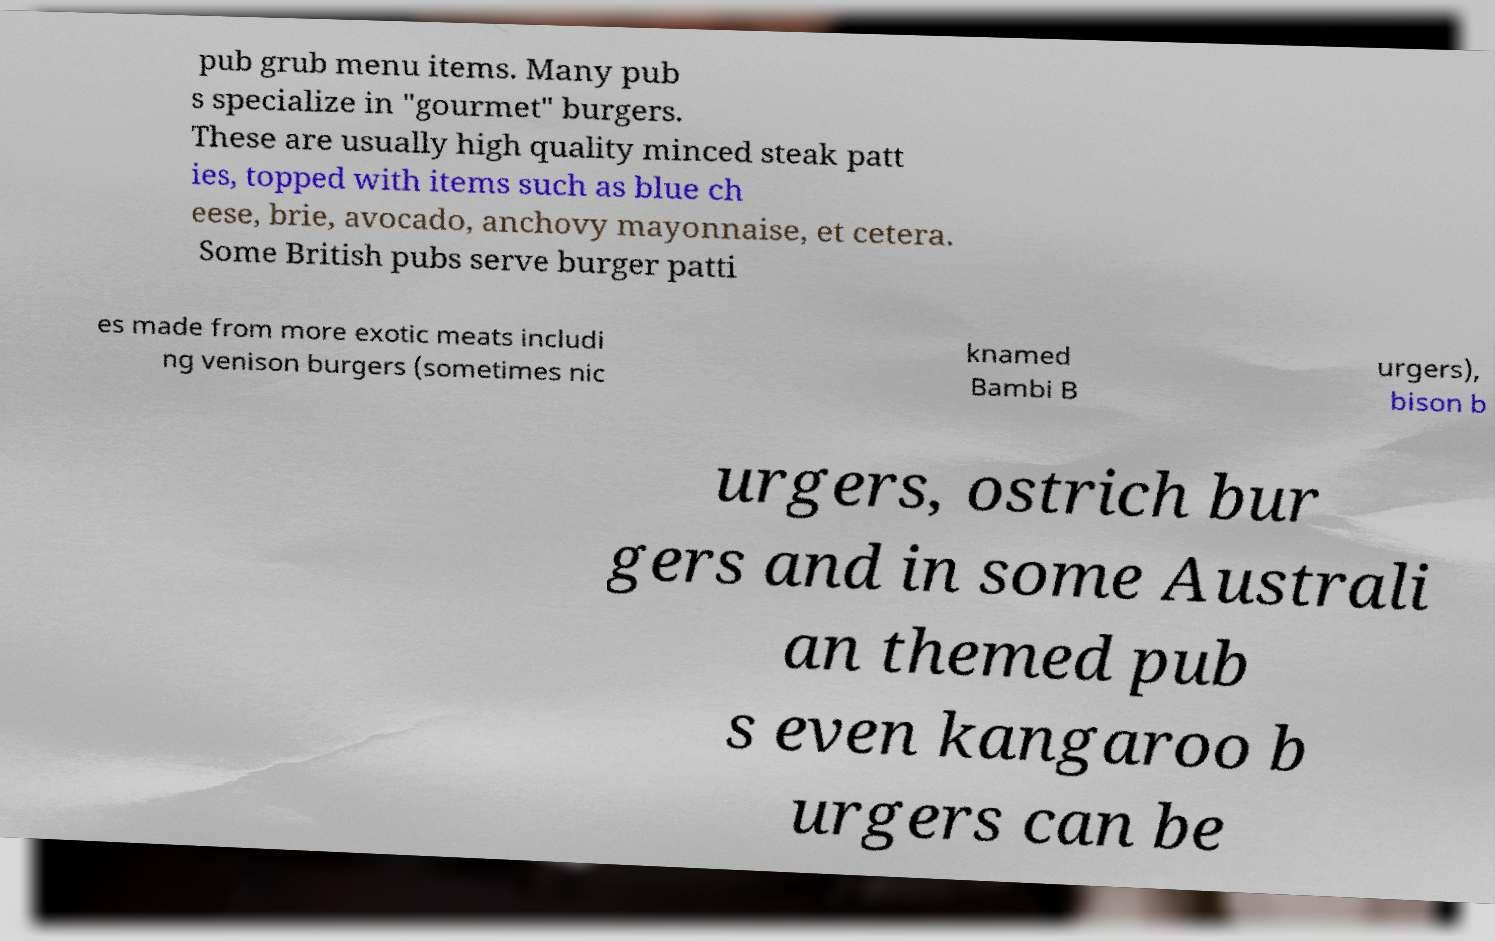There's text embedded in this image that I need extracted. Can you transcribe it verbatim? pub grub menu items. Many pub s specialize in "gourmet" burgers. These are usually high quality minced steak patt ies, topped with items such as blue ch eese, brie, avocado, anchovy mayonnaise, et cetera. Some British pubs serve burger patti es made from more exotic meats includi ng venison burgers (sometimes nic knamed Bambi B urgers), bison b urgers, ostrich bur gers and in some Australi an themed pub s even kangaroo b urgers can be 